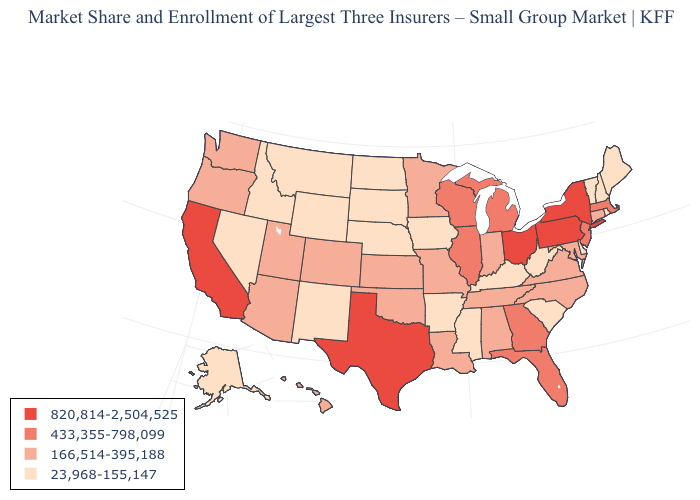Among the states that border South Carolina , which have the highest value?
Be succinct. Georgia. Name the states that have a value in the range 433,355-798,099?
Short answer required. Florida, Georgia, Illinois, Massachusetts, Michigan, New Jersey, Wisconsin. What is the value of Louisiana?
Keep it brief. 166,514-395,188. Does the map have missing data?
Give a very brief answer. No. Among the states that border Tennessee , which have the highest value?
Quick response, please. Georgia. What is the value of South Dakota?
Write a very short answer. 23,968-155,147. Does Hawaii have the lowest value in the West?
Keep it brief. No. Does South Dakota have the lowest value in the MidWest?
Write a very short answer. Yes. Does Colorado have a higher value than Vermont?
Answer briefly. Yes. What is the value of Hawaii?
Short answer required. 166,514-395,188. Which states have the lowest value in the Northeast?
Keep it brief. Maine, New Hampshire, Rhode Island, Vermont. Which states hav the highest value in the Northeast?
Write a very short answer. New York, Pennsylvania. Among the states that border Delaware , which have the highest value?
Write a very short answer. Pennsylvania. What is the value of North Carolina?
Concise answer only. 166,514-395,188. Does Oregon have the highest value in the West?
Be succinct. No. 